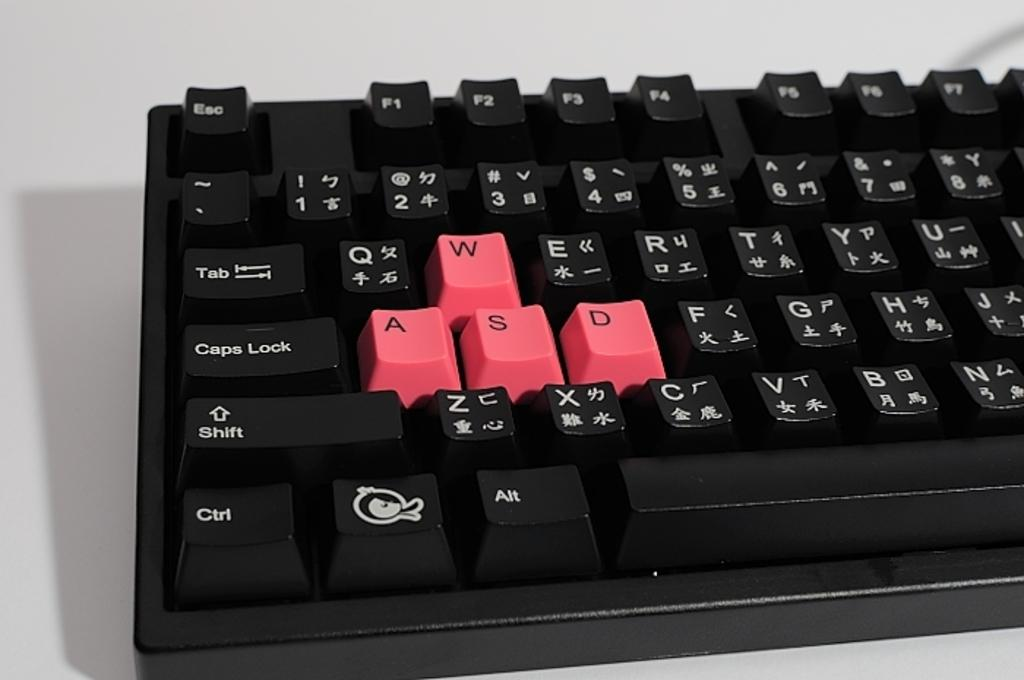Provide a one-sentence caption for the provided image. A keyboard sitting on a white table with the WASD keys marked in red. 